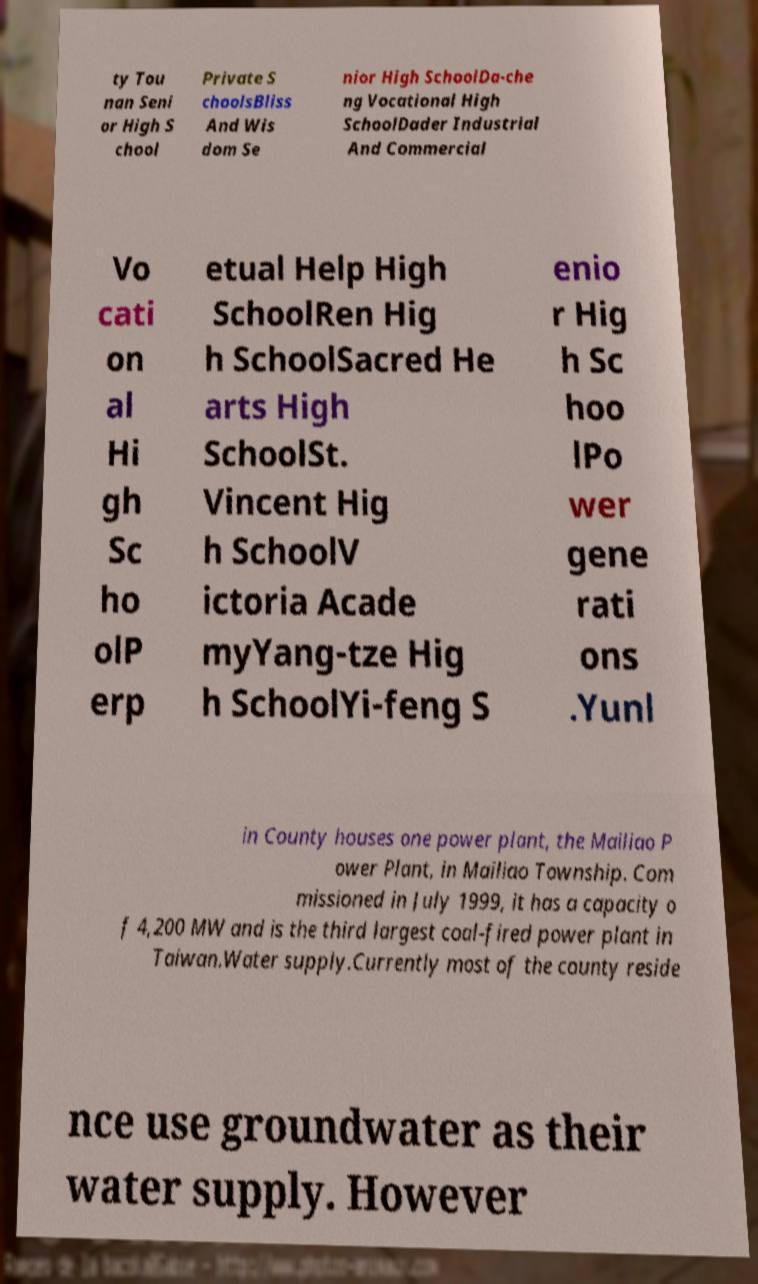Can you accurately transcribe the text from the provided image for me? ty Tou nan Seni or High S chool Private S choolsBliss And Wis dom Se nior High SchoolDa-che ng Vocational High SchoolDader Industrial And Commercial Vo cati on al Hi gh Sc ho olP erp etual Help High SchoolRen Hig h SchoolSacred He arts High SchoolSt. Vincent Hig h SchoolV ictoria Acade myYang-tze Hig h SchoolYi-feng S enio r Hig h Sc hoo lPo wer gene rati ons .Yunl in County houses one power plant, the Mailiao P ower Plant, in Mailiao Township. Com missioned in July 1999, it has a capacity o f 4,200 MW and is the third largest coal-fired power plant in Taiwan.Water supply.Currently most of the county reside nce use groundwater as their water supply. However 